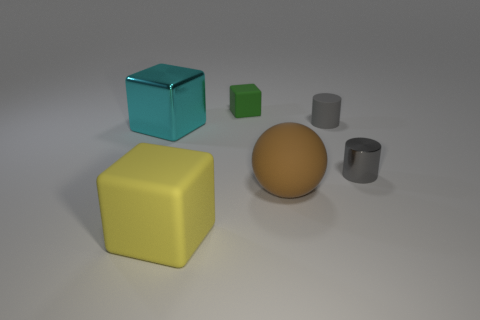Add 4 gray things. How many objects exist? 10 Subtract all balls. How many objects are left? 5 Subtract all large cubes. Subtract all gray shiny cylinders. How many objects are left? 3 Add 1 large yellow rubber blocks. How many large yellow rubber blocks are left? 2 Add 5 big brown matte cylinders. How many big brown matte cylinders exist? 5 Subtract 0 purple cylinders. How many objects are left? 6 